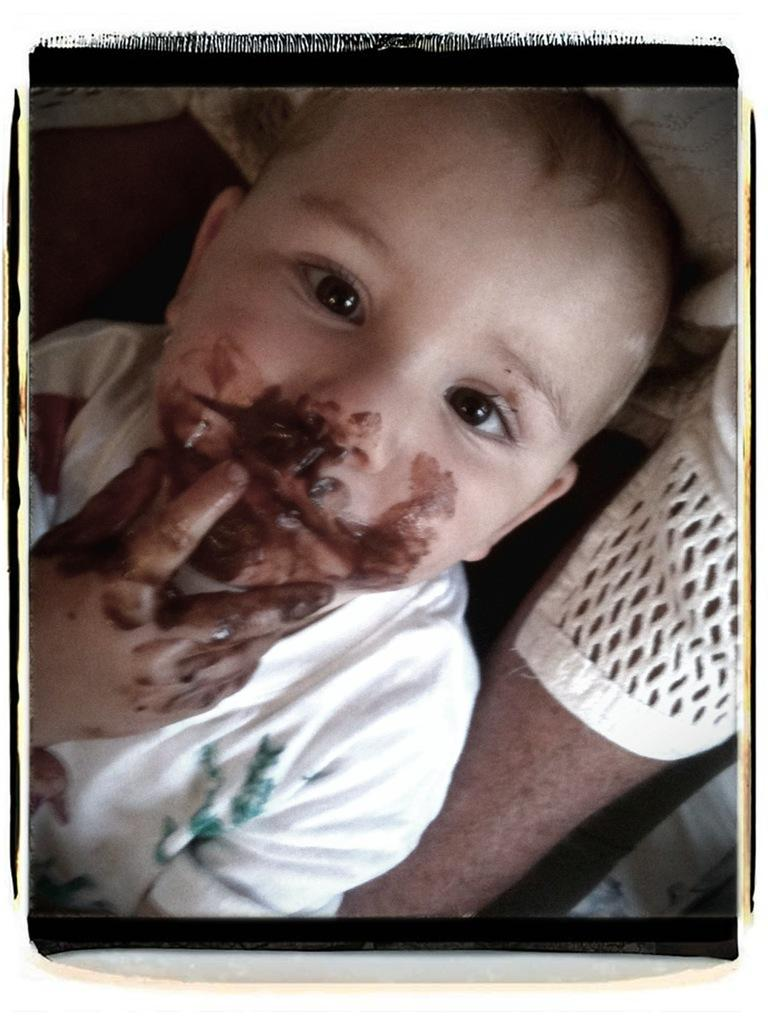What is the main subject of the image? There is a person in the image. Can you describe any specific features of the person? The person has a hand visible in the image. Are there any other people in the image? Yes, there is a boy in the image. What is on the person's face and hand? Chocolate cream is present on the person's face and hand. How many kittens are playing with the band in the image? There are no kittens or bands present in the image. What role does the person play in the society depicted in the image? The image does not depict a society, so it is impossible to determine the person's role in it. 